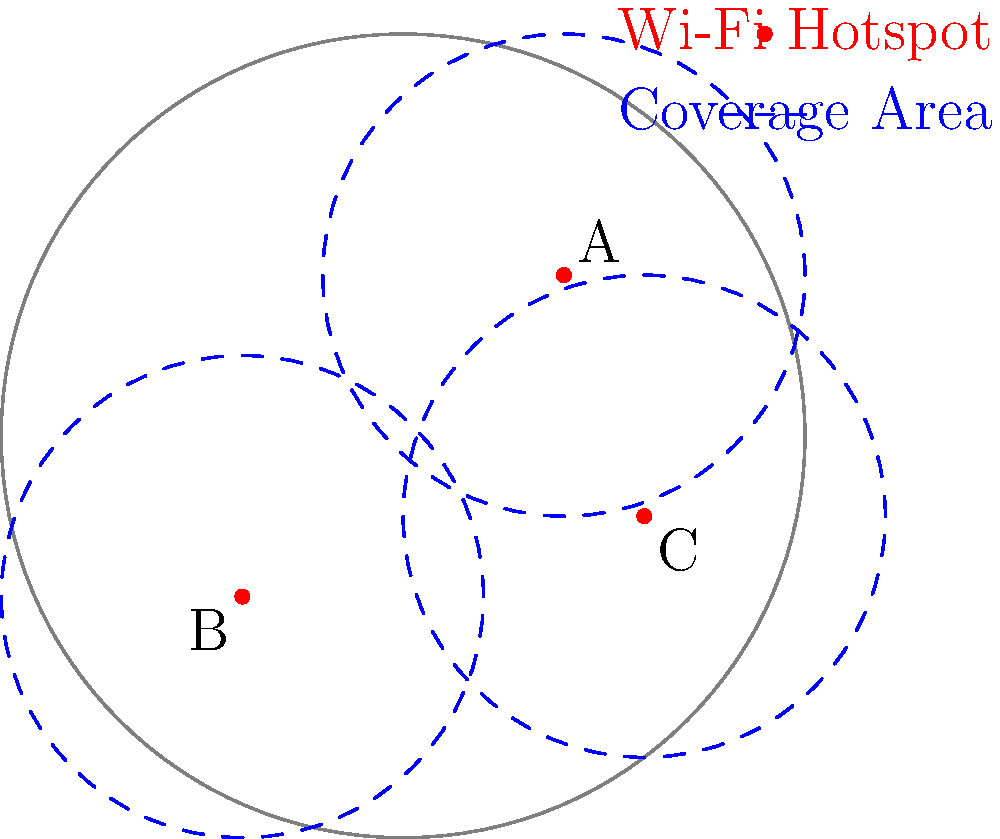In a circular campus quad with a radius of 5 units, three Wi-Fi hotspots (A, B, and C) are placed as shown in the diagram. Each hotspot has a coverage radius of 3 units. What is the central angle (in degrees) of the uncovered arc along the quad's circumference? To solve this problem, we'll follow these steps:

1. Identify the covered areas:
   The Wi-Fi hotspots cover most of the quad, but there's a small uncovered area near the top of the circle.

2. Find the points where the coverage areas intersect the quad's circumference:
   We need to find the angle between these two points.

3. Calculate the central angle of the covered arc:
   a) The quad's circumference is divided into 360°.
   b) The uncovered arc is a small portion of this.
   c) We can estimate that the uncovered arc is approximately 1/12 of the circumference.

4. Calculate the central angle of the uncovered arc:
   a) If 1/12 of the circumference is uncovered, then 11/12 is covered.
   b) The covered portion: $\frac{11}{12} \times 360° = 330°$
   c) The uncovered portion: $360° - 330° = 30°$

Therefore, the central angle of the uncovered arc is approximately 30°.
Answer: 30° 